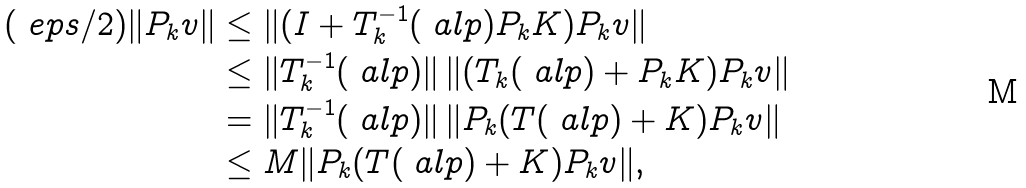<formula> <loc_0><loc_0><loc_500><loc_500>( \ e p s / 2 ) \| P _ { k } v \| & \leq \| ( I + T _ { k } ^ { - 1 } ( \ a l p ) P _ { k } K ) P _ { k } v \| \\ & \leq \| T _ { k } ^ { - 1 } ( \ a l p ) \| \, \| ( T _ { k } ( \ a l p ) + P _ { k } K ) P _ { k } v \| \\ & = \| T _ { k } ^ { - 1 } ( \ a l p ) \| \, \| P _ { k } ( T ( \ a l p ) + K ) P _ { k } v \| \\ & \leq M \| P _ { k } ( T ( \ a l p ) + K ) P _ { k } v \| ,</formula> 